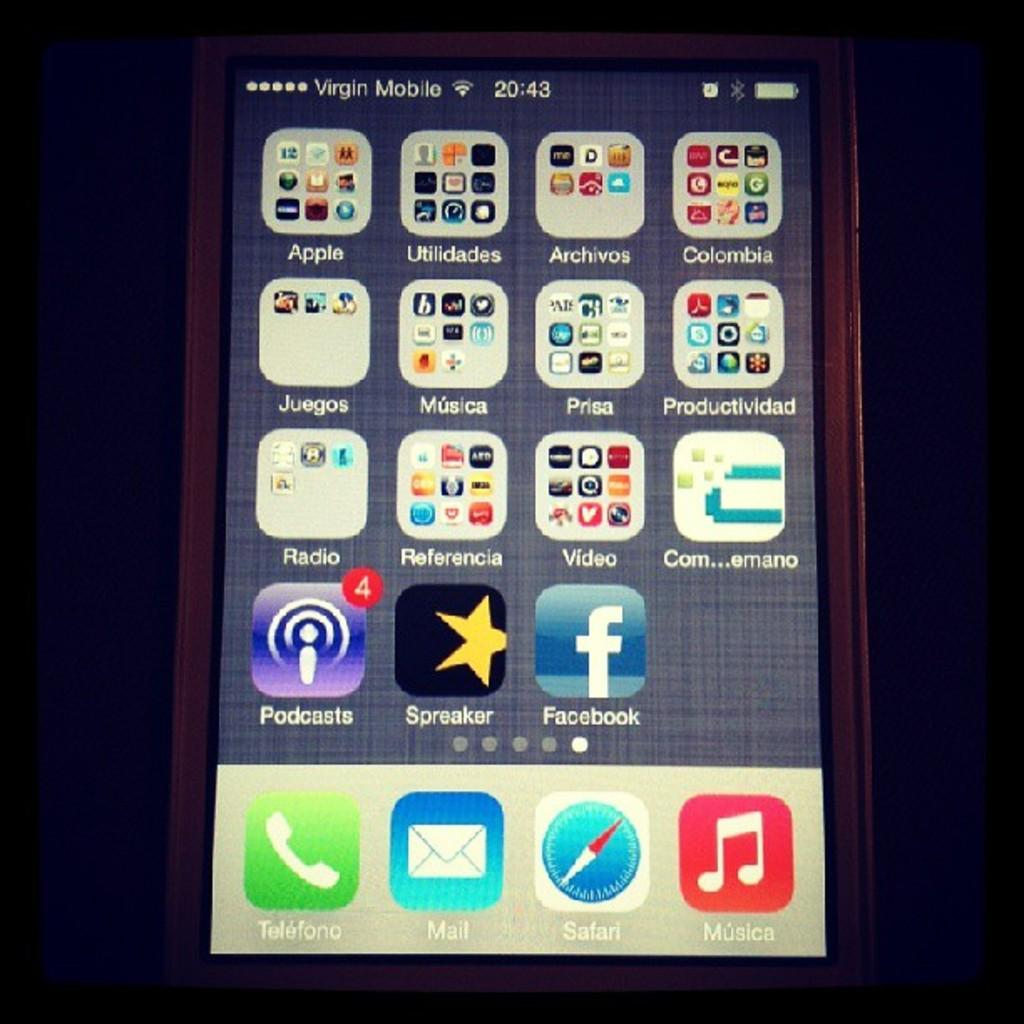Provide a one-sentence caption for the provided image. An iphone is on and has the home screen pulled up with facebook, podcasts and many other apps on it. 